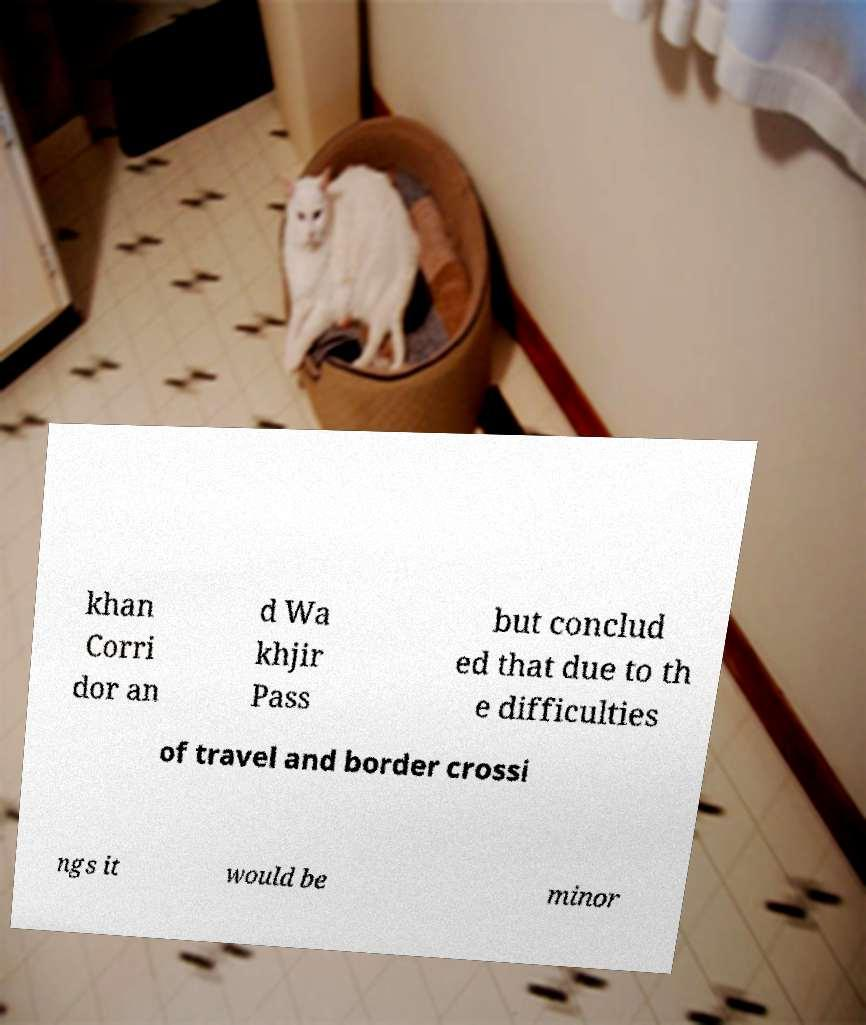There's text embedded in this image that I need extracted. Can you transcribe it verbatim? khan Corri dor an d Wa khjir Pass but conclud ed that due to th e difficulties of travel and border crossi ngs it would be minor 